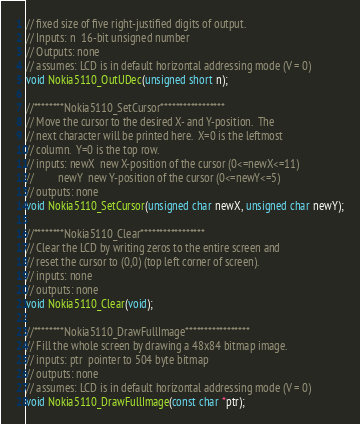Convert code to text. <code><loc_0><loc_0><loc_500><loc_500><_C_>// fixed size of five right-justified digits of output.
// Inputs: n  16-bit unsigned number
// Outputs: none
// assumes: LCD is in default horizontal addressing mode (V = 0)
void Nokia5110_OutUDec(unsigned short n);

//********Nokia5110_SetCursor*****************
// Move the cursor to the desired X- and Y-position.  The
// next character will be printed here.  X=0 is the leftmost
// column.  Y=0 is the top row.
// inputs: newX  new X-position of the cursor (0<=newX<=11)
//         newY  new Y-position of the cursor (0<=newY<=5)
// outputs: none
void Nokia5110_SetCursor(unsigned char newX, unsigned char newY);

//********Nokia5110_Clear*****************
// Clear the LCD by writing zeros to the entire screen and
// reset the cursor to (0,0) (top left corner of screen).
// inputs: none
// outputs: none
void Nokia5110_Clear(void);

//********Nokia5110_DrawFullImage*****************
// Fill the whole screen by drawing a 48x84 bitmap image.
// inputs: ptr  pointer to 504 byte bitmap
// outputs: none
// assumes: LCD is in default horizontal addressing mode (V = 0)
void Nokia5110_DrawFullImage(const char *ptr);
</code> 